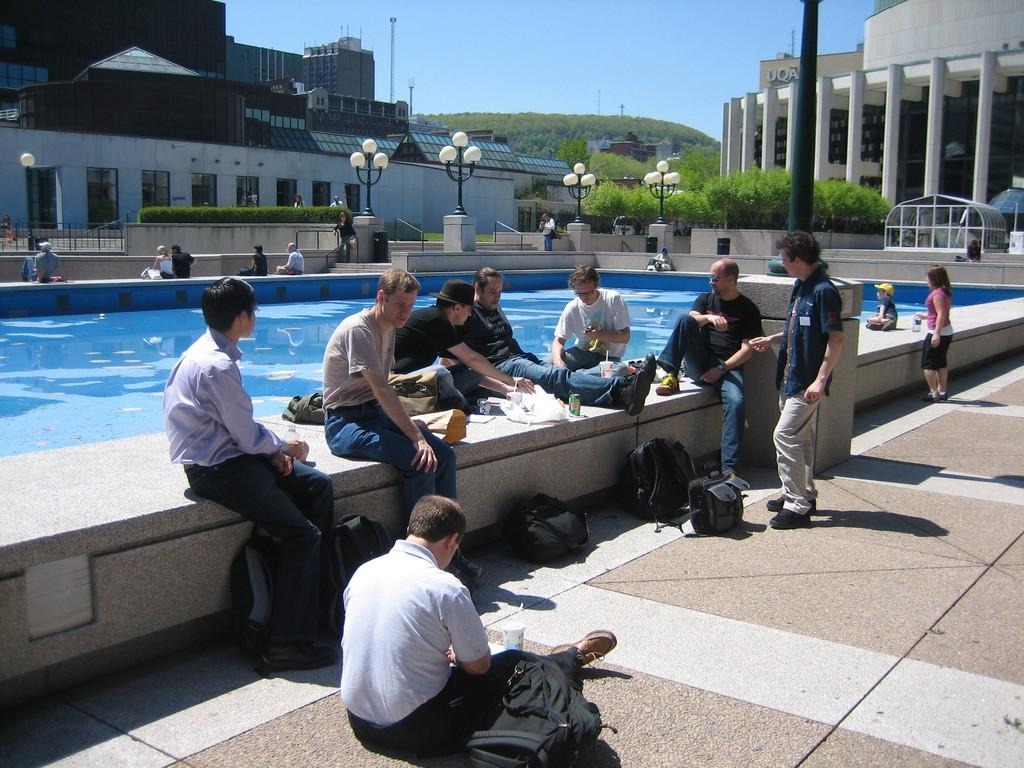What is the main feature in the image? There is a pool in the image. What are the people around the pool doing? The people are sitting around the pool. What else can be seen in the image besides the pool and people? There are buildings, plants, lights, and the sky visible in the image. What type of advice can be heard being given by the silk cream in the image? There is no silk cream present in the image, and therefore no advice can be heard. 